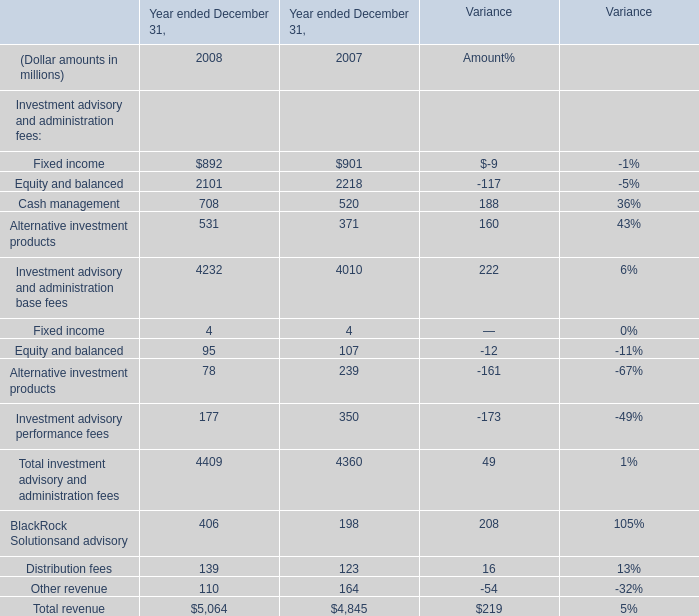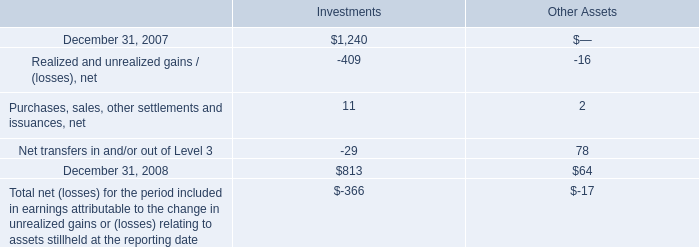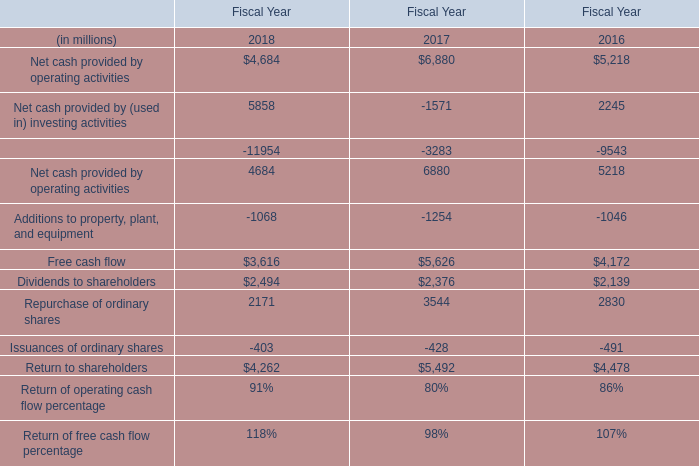What is the sum of Net cash provided by operating activities of Fiscal Year 2016, December 31, 2007 of Investments, and Additions to property, plant, and equipment of Fiscal Year 2016 ? 
Computations: ((5218.0 + 1240.0) + 1046.0)
Answer: 7504.0. 